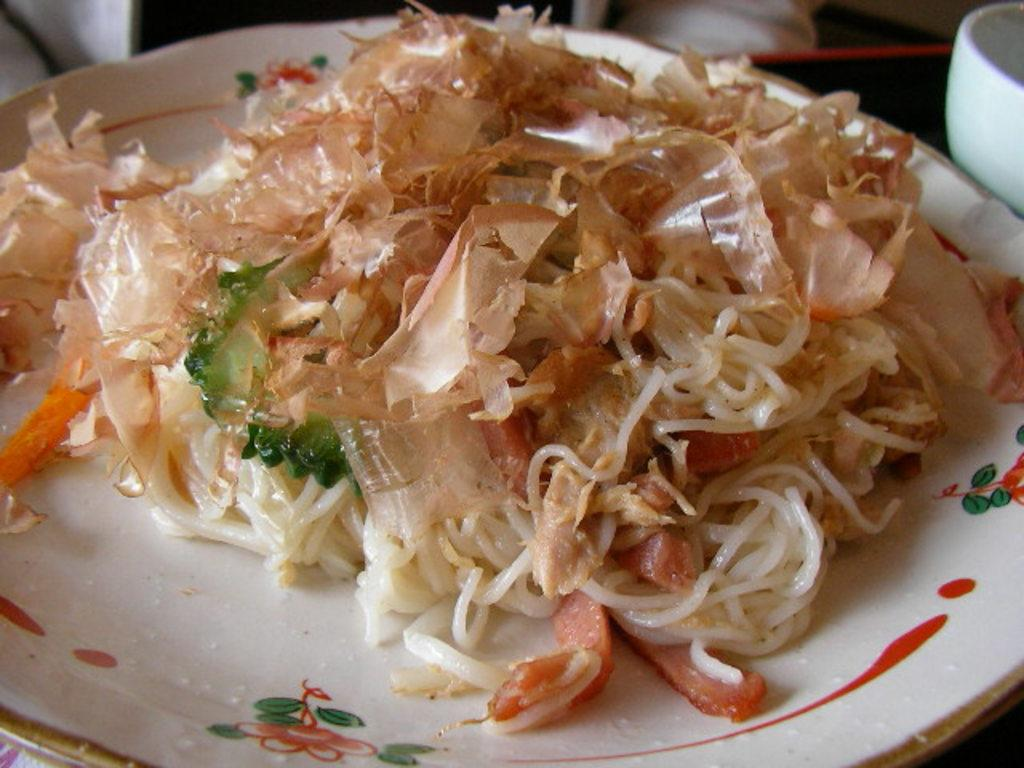What is the main subject of the image? There is a food item on a plate in the image. Can you describe the food item? Unfortunately, the specific food item cannot be determined from the provided facts. What can be seen in the background of the image? There are objects visible in the background of the image, but their nature cannot be determined from the provided facts. How many jellyfish are swimming in the background of the image? There are no jellyfish present in the image. What mass is required to lift the plate in the image? The mass required to lift the plate cannot be determined from the provided facts. 